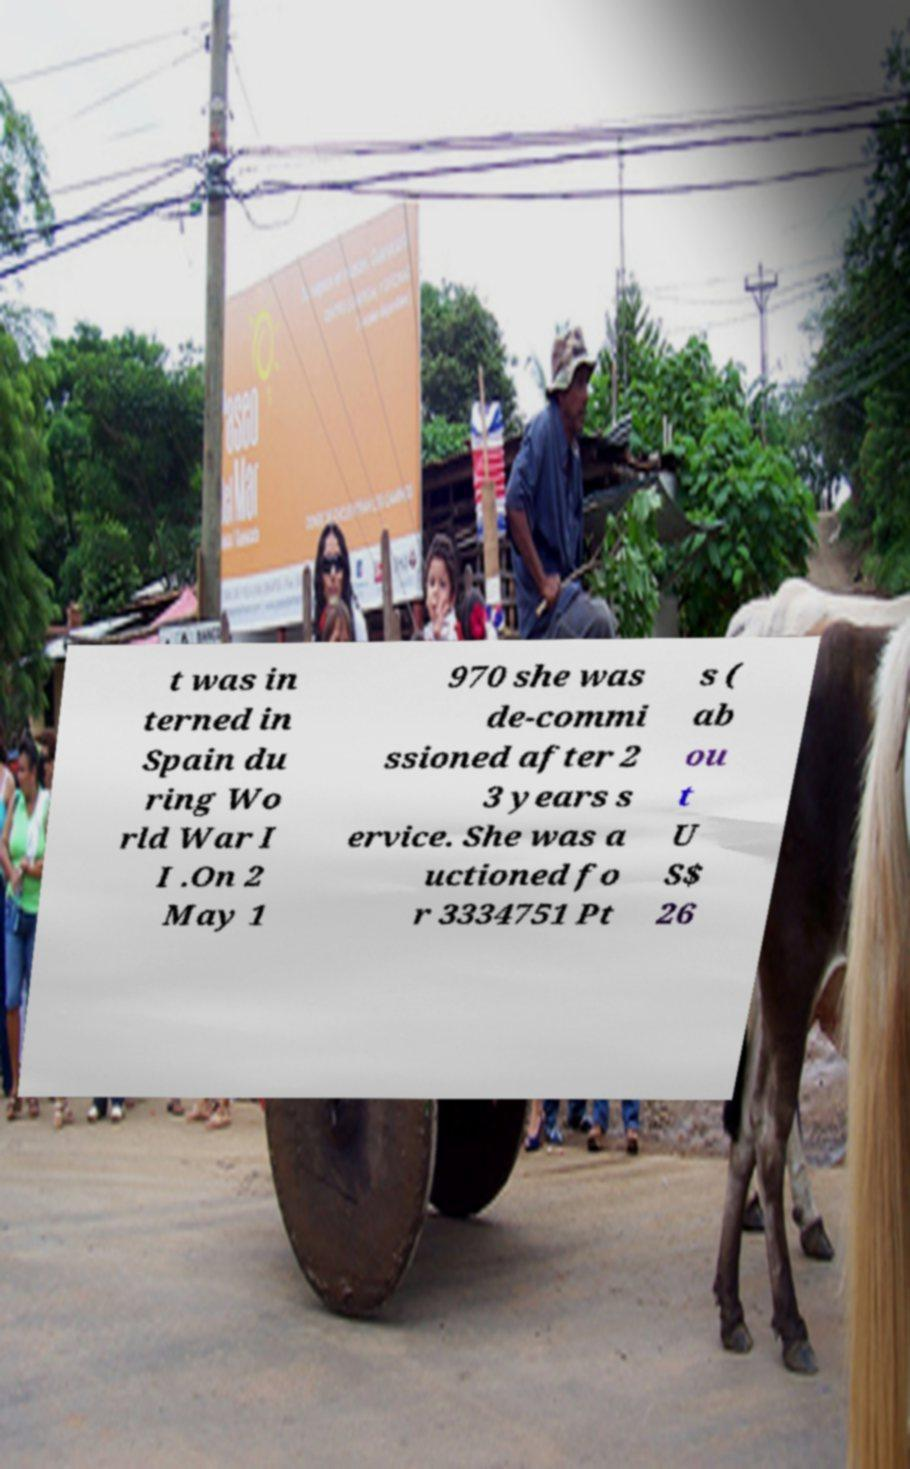For documentation purposes, I need the text within this image transcribed. Could you provide that? t was in terned in Spain du ring Wo rld War I I .On 2 May 1 970 she was de-commi ssioned after 2 3 years s ervice. She was a uctioned fo r 3334751 Pt s ( ab ou t U S$ 26 